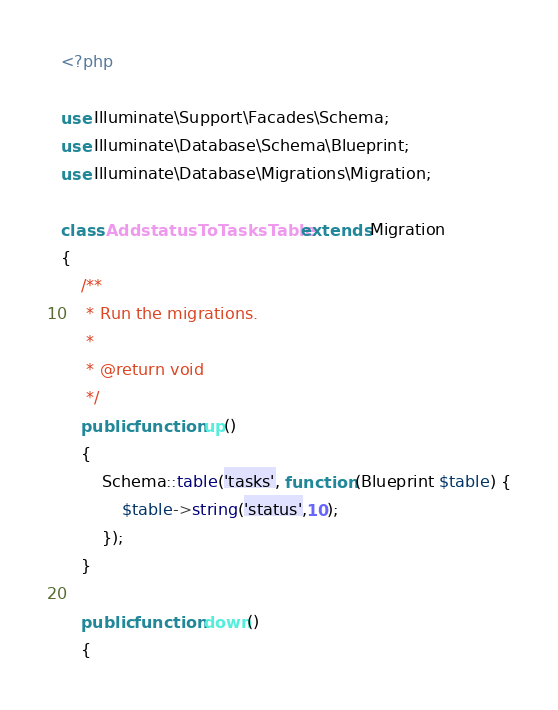<code> <loc_0><loc_0><loc_500><loc_500><_PHP_><?php

use Illuminate\Support\Facades\Schema;
use Illuminate\Database\Schema\Blueprint;
use Illuminate\Database\Migrations\Migration;

class AddstatusToTasksTable extends Migration
{
    /**
     * Run the migrations.
     *
     * @return void
     */
    public function up()
    {
        Schema::table('tasks', function (Blueprint $table) {
            $table->string('status',10);
        });
    }

    public function down()
    {</code> 